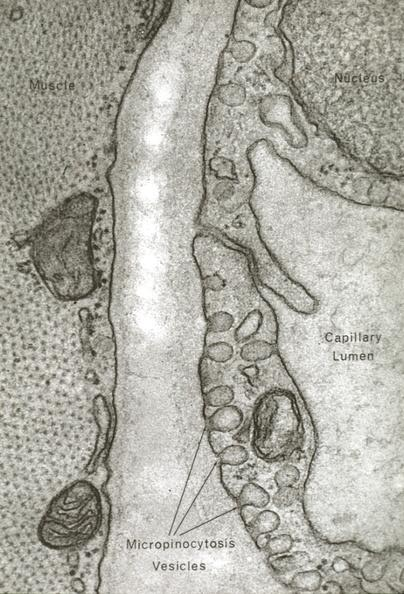s beckwith-wiedemann syndrome present?
Answer the question using a single word or phrase. No 